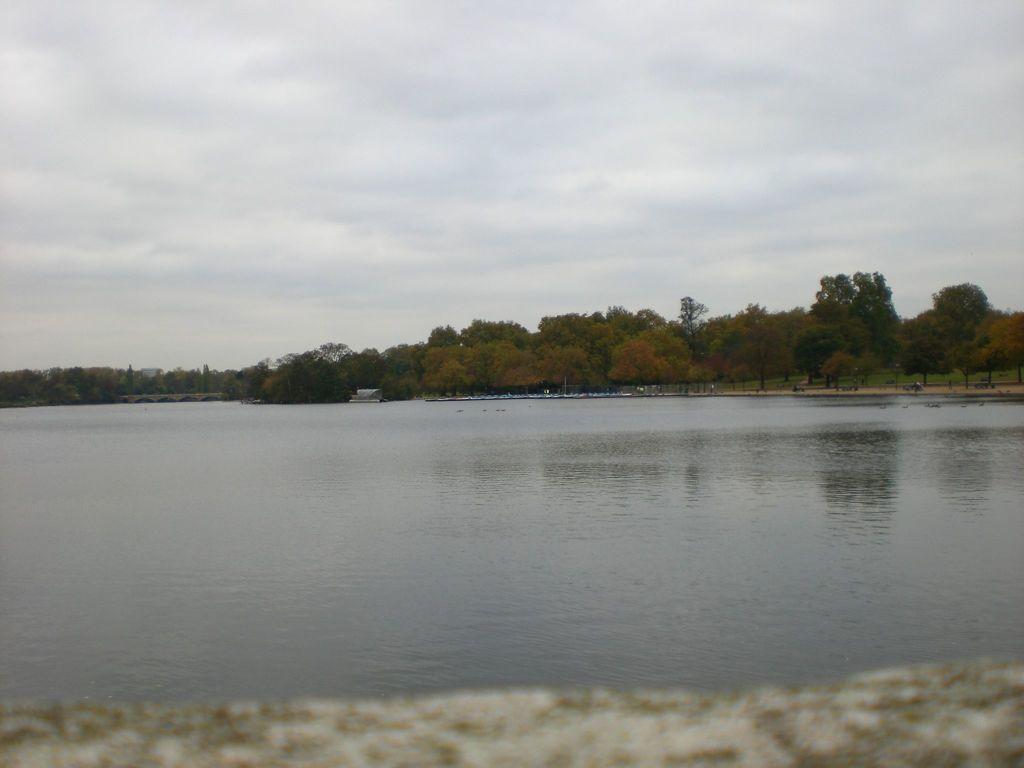Could you give a brief overview of what you see in this image? In this picture we can see water, in the background we can see few trees and clouds. 